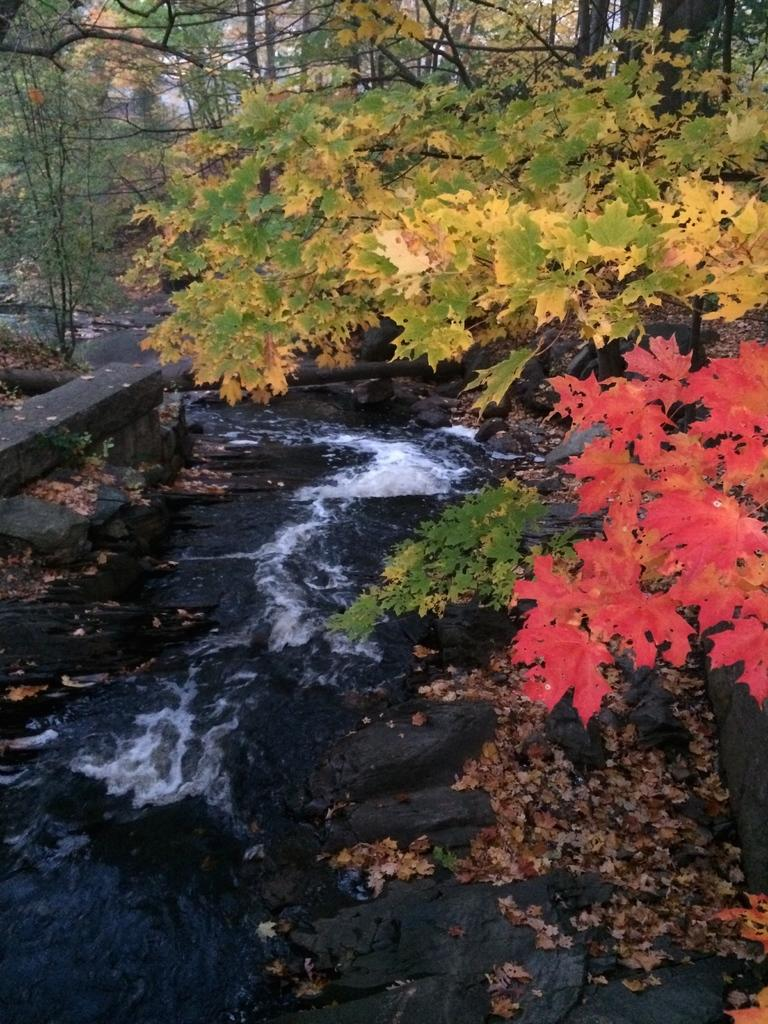What is the main feature of the image? The main feature of the image is flowing water. What else can be seen in the image besides the flowing water? Shredded leaves, rocks, plants, trees, and creepers are present in the image. Can you describe the plants and trees in the image? The plants are small and the trees are tall, with some having creepers growing on them. How many goldfish can be seen swimming in the water in the image? There are no goldfish present in the image; it features flowing water with other elements like shredded leaves, rocks, plants, trees, and creepers. 